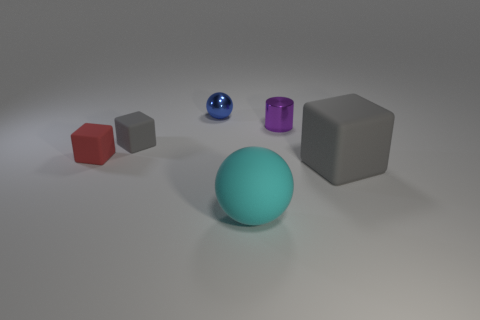Is the color of the block in front of the red rubber cube the same as the small matte thing that is behind the tiny red thing?
Ensure brevity in your answer.  Yes. There is a matte block that is right of the tiny gray rubber cube; what is its color?
Provide a succinct answer. Gray. What is the shape of the tiny thing that is left of the blue shiny thing and behind the red cube?
Provide a short and direct response. Cube. What number of big cyan rubber things have the same shape as the tiny purple object?
Your answer should be compact. 0. How many tiny red cylinders are there?
Provide a short and direct response. 0. What is the size of the object that is both in front of the red rubber object and on the left side of the small purple metal cylinder?
Give a very brief answer. Large. What is the shape of the other metal object that is the same size as the purple metal thing?
Provide a short and direct response. Sphere. There is a large object that is to the left of the tiny purple cylinder; is there a small gray block that is in front of it?
Provide a succinct answer. No. What color is the small shiny object that is the same shape as the cyan matte thing?
Give a very brief answer. Blue. Does the rubber object that is behind the red thing have the same color as the big rubber cube?
Your response must be concise. Yes. 